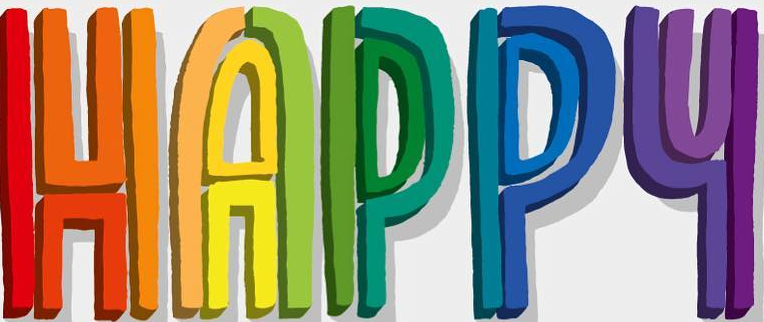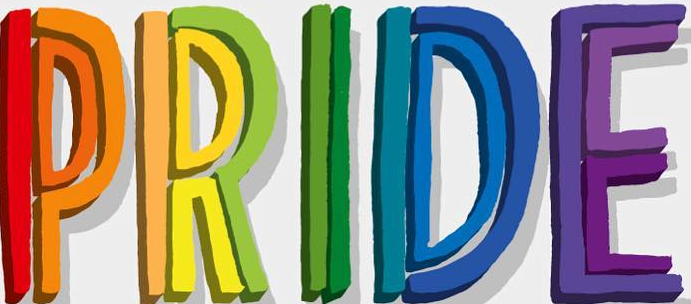What words can you see in these images in sequence, separated by a semicolon? HAPPY; PRIDE 